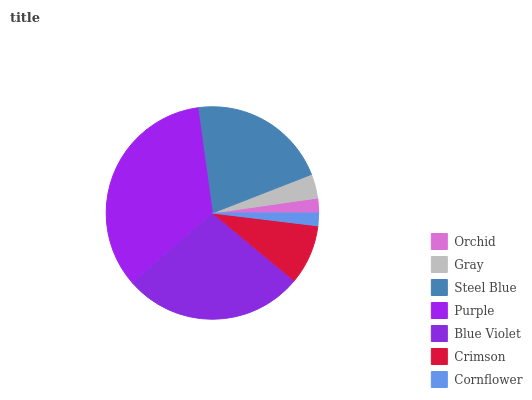Is Cornflower the minimum?
Answer yes or no. Yes. Is Purple the maximum?
Answer yes or no. Yes. Is Gray the minimum?
Answer yes or no. No. Is Gray the maximum?
Answer yes or no. No. Is Gray greater than Orchid?
Answer yes or no. Yes. Is Orchid less than Gray?
Answer yes or no. Yes. Is Orchid greater than Gray?
Answer yes or no. No. Is Gray less than Orchid?
Answer yes or no. No. Is Crimson the high median?
Answer yes or no. Yes. Is Crimson the low median?
Answer yes or no. Yes. Is Gray the high median?
Answer yes or no. No. Is Steel Blue the low median?
Answer yes or no. No. 